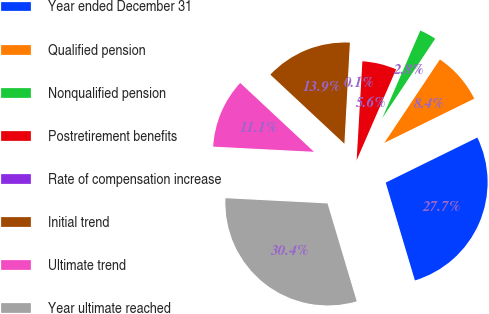<chart> <loc_0><loc_0><loc_500><loc_500><pie_chart><fcel>Year ended December 31<fcel>Qualified pension<fcel>Nonqualified pension<fcel>Postretirement benefits<fcel>Rate of compensation increase<fcel>Initial trend<fcel>Ultimate trend<fcel>Year ultimate reached<nl><fcel>27.66%<fcel>8.37%<fcel>2.83%<fcel>5.6%<fcel>0.06%<fcel>13.91%<fcel>11.14%<fcel>30.43%<nl></chart> 